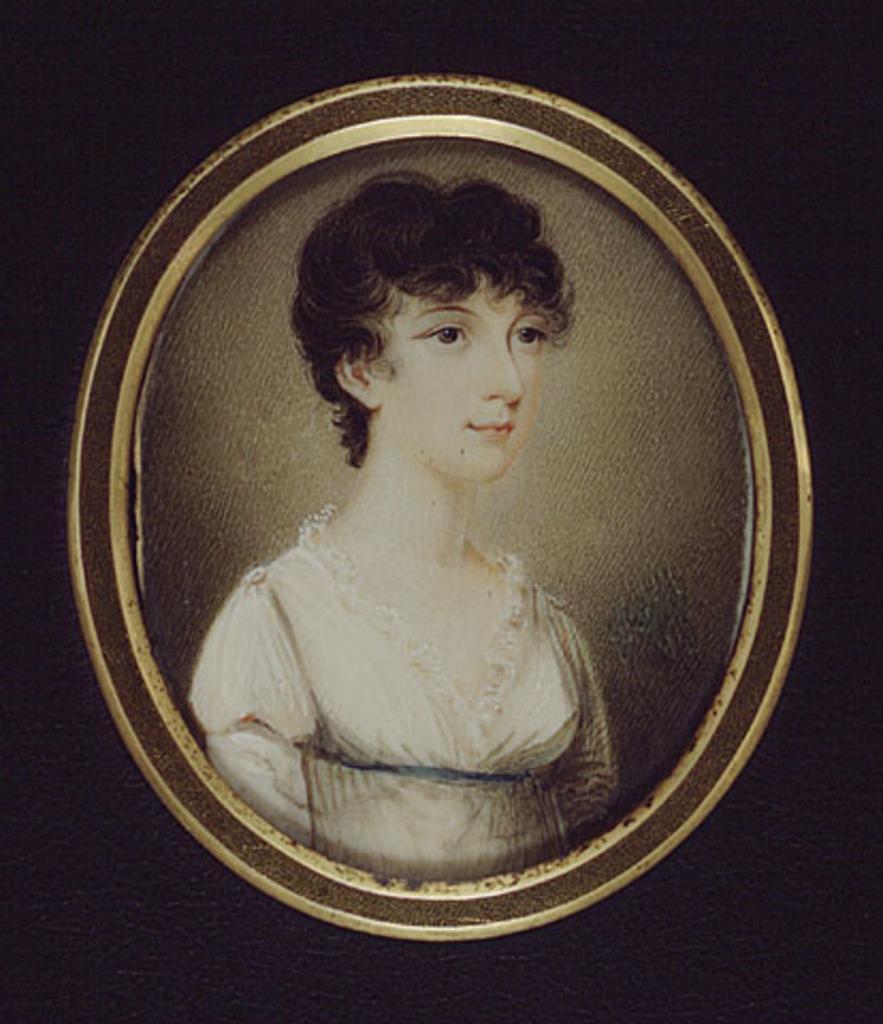In one or two sentences, can you explain what this image depicts? By seeing this image we can say it is a painting of a lady. 